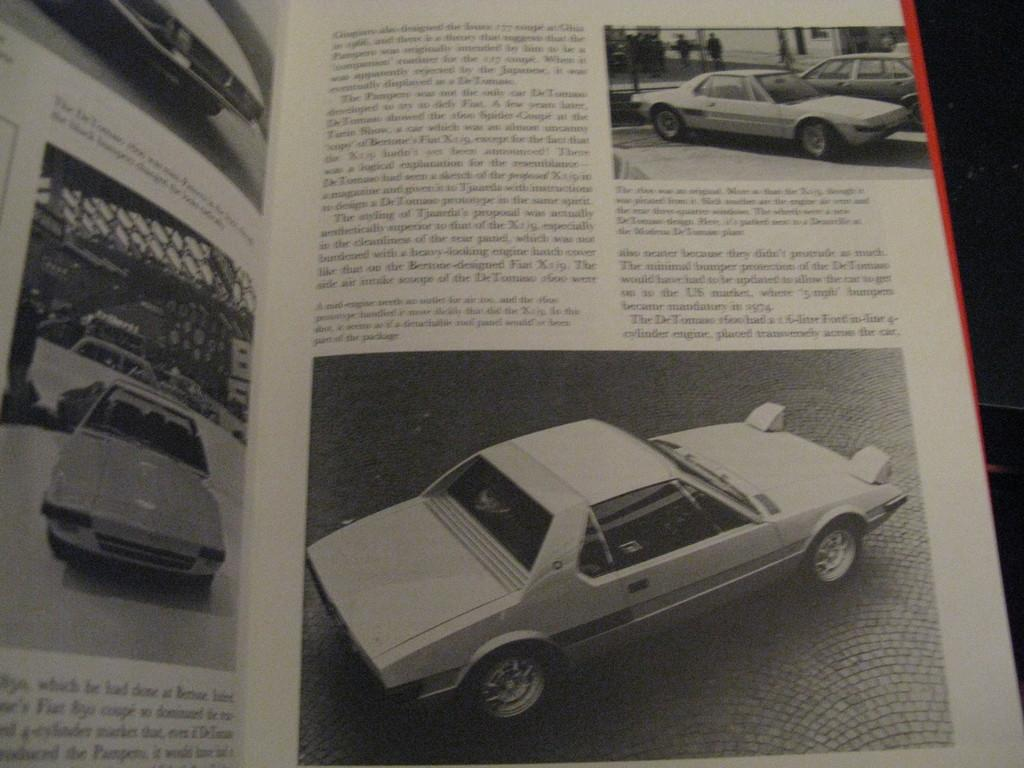What is the main subject of the book in the image? The book contains black and white images of cars. What type of matter is present in the book? The book contains matter, which is likely the paper it is printed on. What type of train can be seen in the image? There is no train present in the image; the book contains images of cars. How many toys are visible in the image? There are no toys visible in the image; the book contains images of cars. 